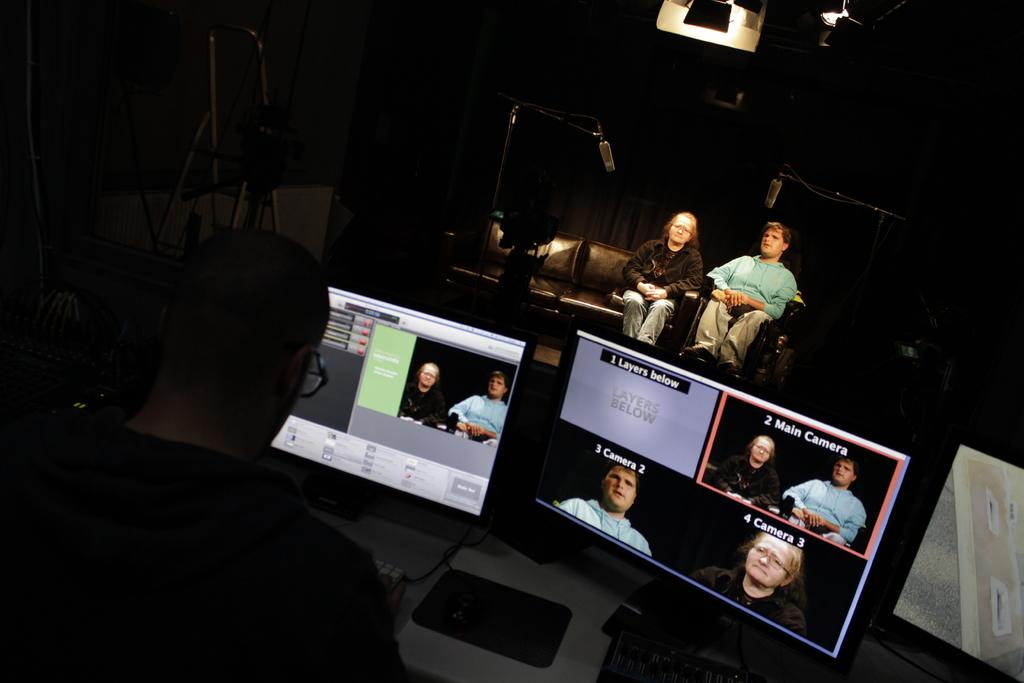<image>
Give a short and clear explanation of the subsequent image. computer screens with pictures on them and one of them labeled '2 main camera' 